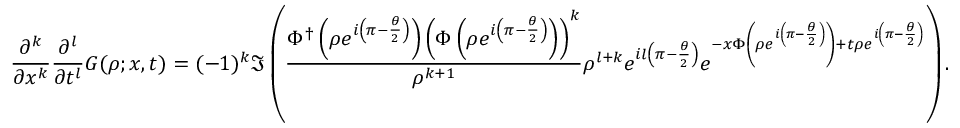Convert formula to latex. <formula><loc_0><loc_0><loc_500><loc_500>\frac { \partial ^ { k } } { \partial x ^ { k } } \frac { \partial ^ { l } } { \partial t ^ { l } } G ( \rho ; x , t ) = ( - 1 ) ^ { k } \Im \left ( \frac { \Phi ^ { \dagger } \left ( \rho e ^ { i \left ( \pi - \frac { \theta } { 2 } \right ) } \right ) \left ( \Phi \left ( \rho e ^ { i \left ( \pi - \frac { \theta } { 2 } \right ) } \right ) \right ) ^ { k } } { \rho ^ { k + 1 } } \rho ^ { l + k } e ^ { i l \left ( \pi - \frac { \theta } { 2 } \right ) } e ^ { - x \Phi \left ( \rho e ^ { i \left ( \pi - \frac { \theta } { 2 } \right ) } \right ) + t \rho e ^ { i \left ( \pi - \frac { \theta } { 2 } \right ) } } \right ) .</formula> 